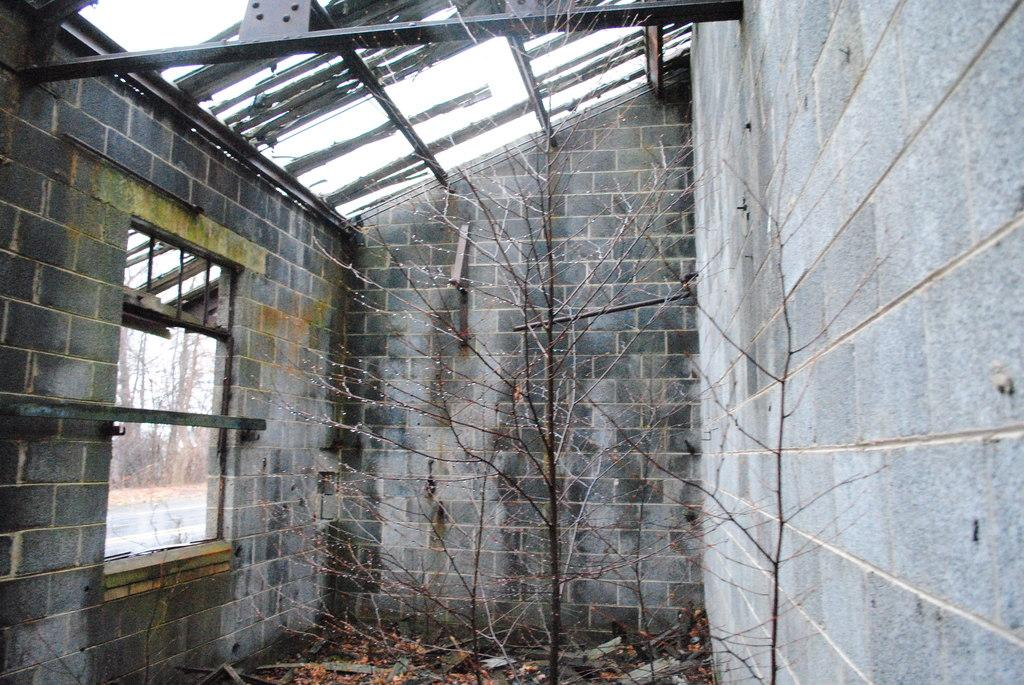What is the main structure in the center of the image? There is a building in the center of the image. What are the main components of the building? The building has a wall, window, and roof. What can be seen in the center of the image besides the building? There is a tree in the center of the image. What is visible in the background of the image? The sky is visible in the background of the image, and clouds are present. What can be seen through the window of the building? Trees, grass, and a road are visible through the window. How does the kitten contribute to the science experiment in the image? There is no kitten or science experiment present in the image. What type of motion is the building exhibiting in the image? The building is not exhibiting any motion in the image; it is stationary. 